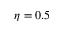<formula> <loc_0><loc_0><loc_500><loc_500>\eta = 0 . 5</formula> 